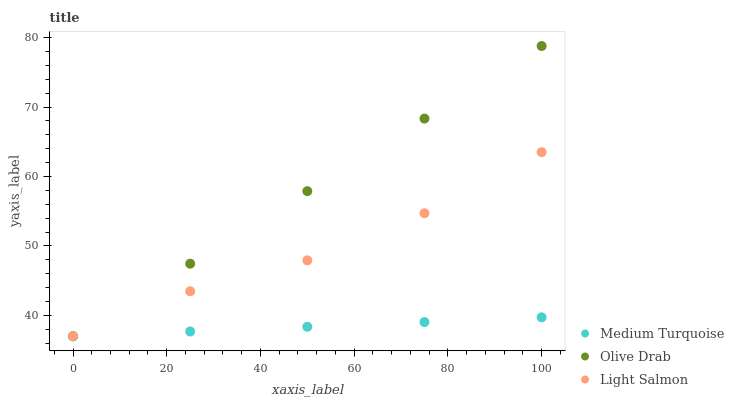Does Medium Turquoise have the minimum area under the curve?
Answer yes or no. Yes. Does Olive Drab have the maximum area under the curve?
Answer yes or no. Yes. Does Olive Drab have the minimum area under the curve?
Answer yes or no. No. Does Medium Turquoise have the maximum area under the curve?
Answer yes or no. No. Is Medium Turquoise the smoothest?
Answer yes or no. Yes. Is Light Salmon the roughest?
Answer yes or no. Yes. Is Olive Drab the smoothest?
Answer yes or no. No. Is Olive Drab the roughest?
Answer yes or no. No. Does Light Salmon have the lowest value?
Answer yes or no. Yes. Does Olive Drab have the highest value?
Answer yes or no. Yes. Does Medium Turquoise have the highest value?
Answer yes or no. No. Does Medium Turquoise intersect Olive Drab?
Answer yes or no. Yes. Is Medium Turquoise less than Olive Drab?
Answer yes or no. No. Is Medium Turquoise greater than Olive Drab?
Answer yes or no. No. 